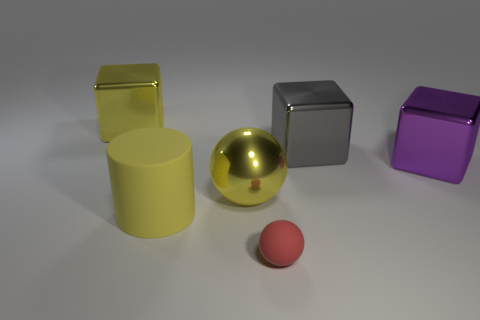Is the large cylinder the same color as the large shiny sphere?
Offer a terse response. Yes. There is a large cube to the left of the big yellow rubber cylinder; is its color the same as the big matte object?
Provide a short and direct response. Yes. There is a ball that is the same material as the big cylinder; what size is it?
Keep it short and to the point. Small. How many big things are in front of the gray shiny cube and to the left of the red rubber sphere?
Your answer should be compact. 2. How many objects are cyan rubber cubes or large cubes that are to the right of the yellow metal ball?
Give a very brief answer. 2. There is a metallic object that is the same color as the large metal ball; what shape is it?
Ensure brevity in your answer.  Cube. What is the color of the large metallic cube that is left of the small thing?
Keep it short and to the point. Yellow. How many objects are things behind the small red object or metallic balls?
Your response must be concise. 5. There is a shiny sphere that is the same size as the gray metal block; what is its color?
Offer a terse response. Yellow. Are there more small red spheres that are in front of the large ball than tiny metal cylinders?
Offer a terse response. Yes. 